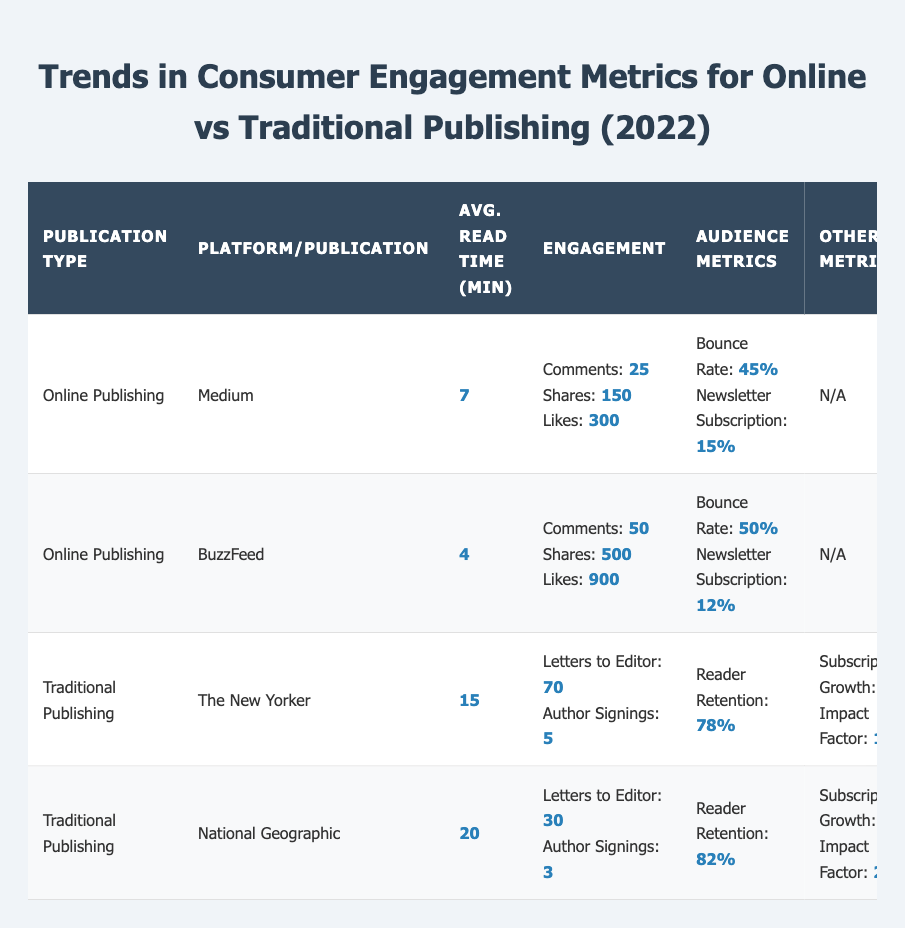What is the average read time for articles on Medium? The table lists the average read time for Medium under the online publishing section, which is 7 minutes.
Answer: 7 minutes How many likes per article does BuzzFeed receive? BuzzFeed's likes per article metric is directly provided in the table, showing 900 likes.
Answer: 900 likes Which traditional publication has a higher reader retention rate? The reader retention rates for The New Yorker (78%) and National Geographic (82%) are provided. Since 82% is greater than 78%, National Geographic has a higher reader retention rate.
Answer: National Geographic What is the difference in average read time between online and traditional publishing publications? For online publishing, the average read times are 7 minutes (Medium) and 4 minutes (BuzzFeed), which averages to (7 + 4) / 2 = 5.5 minutes. For traditional publishing, the average read times are 15 minutes (The New Yorker) and 20 minutes (National Geographic), which averages to (15 + 20) / 2 = 17.5 minutes. The difference is 17.5 - 5.5 = 12 minutes.
Answer: 12 minutes Is the newsletter subscription rate higher for online publishing compared to traditional publishing? The newsletter subscription rates mentioned are 15% for Medium, 12% for BuzzFeed (both online) and there are no rates for traditional publishing. Therefore, there is insufficient data for traditional publishing to make a comparison.
Answer: Insufficient data What is the total number of letters to the editor per issue for both traditional publications? The New Yorker has 70 letters to the editor, and National Geographic has 30. Adding these gives a total of 70 + 30 = 100 letters per issue for both publications combined.
Answer: 100 letters Which platform has the highest shares per article? BuzzFeed shows the highest shares at 500, while Medium has 150 shares. Comparing these values, 500 is greater than 150, indicating BuzzFeed has the highest shares per article.
Answer: BuzzFeed What percentage of subscriptions growth does National Geographic demonstrate? The subscriptions growth percentage for National Geographic is explicitly given as 4%.
Answer: 4% Does the average read time for traditional publications exceed that of online publications? The average read times are 15 minutes for The New Yorker and 20 minutes for National Geographic, with an average of (15 + 20) / 2 = 17.5 minutes for traditional publications; compared to (7 + 4) / 2 = 5.5 minutes for online publications, we find that 17.5 minutes exceeds 5.5 minutes.
Answer: Yes 